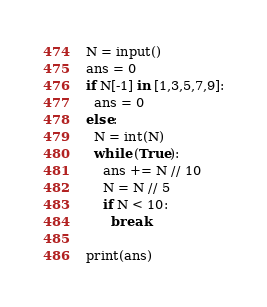Convert code to text. <code><loc_0><loc_0><loc_500><loc_500><_Python_>N = input()
ans = 0
if N[-1] in [1,3,5,7,9]:
  ans = 0
else:
  N = int(N)
  while (True):
    ans += N // 10
    N = N // 5
    if N < 10:
      break

print(ans)</code> 